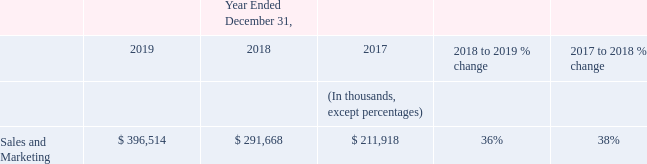Sales and Marketing Expenses
Sales and marketing expenses increased $105 million, or 36%, in 2019 compared to 2018. The overall increase was primarily due to increased employee compensation-related costs, including
amortization of capitalized commissions, of $72 million, driven by headcount growth, and an increase in marketing program costs of $8 million. The increase in marketing program costs was driven by increased volume of advertising activities. Further contributing to the overall increase was an increase in allocated shared costs of $14 million.
Sales and marketing expenses increased $80 million, or 38%, in 2018 compared to 2017. The overall increase was primarily due to increased employee compensation-related costs, including amortization of capitalized commissions, of $55 million, driven by headcount growth, and an increase in marketing program costs of $10 million. The increase in marketing program costs was driven by increased volume of advertising activities. Further contributing to the overall increase was an increase in allocated shared costs of $11 million.
What was the increase in marketing program costs from 2017 to 2018? $10 million. What is the difference between the increase sales and marketing expenses from 2018 to 2019 and 2017 to 2018?
Answer scale should be: million. 105 - 80 
Answer: 25. What is the driver for an increase in marketing program costs from 2018 to 2019? The increase in marketing program costs was driven by increased volume of advertising activities. What is the percentage increase in sales and marketing expenses from 2017 to 2019?
Answer scale should be: percent. (396,514 - 211,918) / 211,918 
Answer: 87.11. What was the percentage increase in sales and marketing expenses from 2018 to 2019? 36%. What was the increase in sales and marketing expenses from 2017 to 2019?
Answer scale should be: million. 80 + 105 
Answer: 185. 